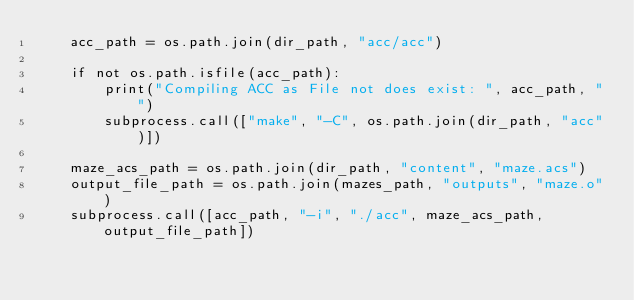<code> <loc_0><loc_0><loc_500><loc_500><_Python_>    acc_path = os.path.join(dir_path, "acc/acc")

    if not os.path.isfile(acc_path):
        print("Compiling ACC as File not does exist: ", acc_path, "")
        subprocess.call(["make", "-C", os.path.join(dir_path, "acc")])

    maze_acs_path = os.path.join(dir_path, "content", "maze.acs")
    output_file_path = os.path.join(mazes_path, "outputs", "maze.o")
    subprocess.call([acc_path, "-i", "./acc", maze_acs_path, output_file_path])
</code> 